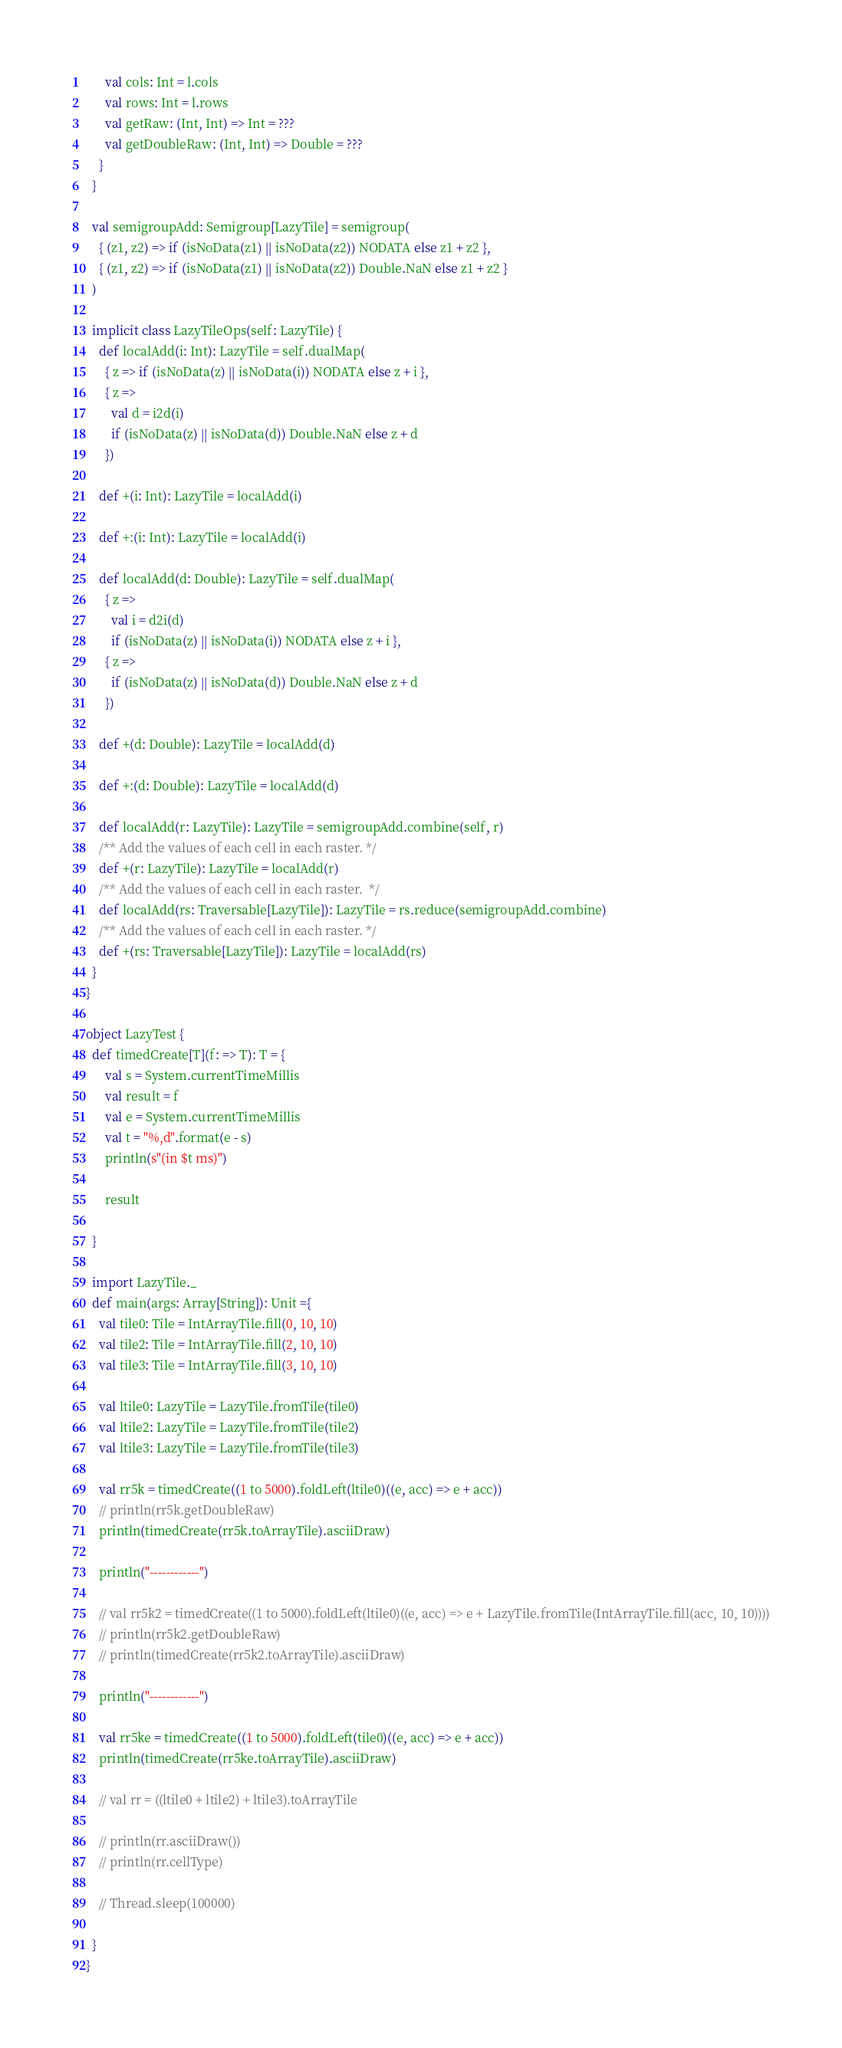<code> <loc_0><loc_0><loc_500><loc_500><_Scala_>      val cols: Int = l.cols
      val rows: Int = l.rows
      val getRaw: (Int, Int) => Int = ???
      val getDoubleRaw: (Int, Int) => Double = ???
    }
  }

  val semigroupAdd: Semigroup[LazyTile] = semigroup(
    { (z1, z2) => if (isNoData(z1) || isNoData(z2)) NODATA else z1 + z2 },
    { (z1, z2) => if (isNoData(z1) || isNoData(z2)) Double.NaN else z1 + z2 }
  )

  implicit class LazyTileOps(self: LazyTile) {
    def localAdd(i: Int): LazyTile = self.dualMap(
      { z => if (isNoData(z) || isNoData(i)) NODATA else z + i },
      { z =>
        val d = i2d(i)
        if (isNoData(z) || isNoData(d)) Double.NaN else z + d
      })

    def +(i: Int): LazyTile = localAdd(i)

    def +:(i: Int): LazyTile = localAdd(i)

    def localAdd(d: Double): LazyTile = self.dualMap(
      { z =>
        val i = d2i(d)
        if (isNoData(z) || isNoData(i)) NODATA else z + i },
      { z =>
        if (isNoData(z) || isNoData(d)) Double.NaN else z + d
      })

    def +(d: Double): LazyTile = localAdd(d)

    def +:(d: Double): LazyTile = localAdd(d)

    def localAdd(r: LazyTile): LazyTile = semigroupAdd.combine(self, r)
    /** Add the values of each cell in each raster. */
    def +(r: LazyTile): LazyTile = localAdd(r)
    /** Add the values of each cell in each raster.  */
    def localAdd(rs: Traversable[LazyTile]): LazyTile = rs.reduce(semigroupAdd.combine)
    /** Add the values of each cell in each raster. */
    def +(rs: Traversable[LazyTile]): LazyTile = localAdd(rs)
  }
}

object LazyTest {
  def timedCreate[T](f: => T): T = {
      val s = System.currentTimeMillis
      val result = f
      val e = System.currentTimeMillis
      val t = "%,d".format(e - s)
      println(s"(in $t ms)")

      result

  }

  import LazyTile._
  def main(args: Array[String]): Unit ={
    val tile0: Tile = IntArrayTile.fill(0, 10, 10)
    val tile2: Tile = IntArrayTile.fill(2, 10, 10)
    val tile3: Tile = IntArrayTile.fill(3, 10, 10)

    val ltile0: LazyTile = LazyTile.fromTile(tile0)
    val ltile2: LazyTile = LazyTile.fromTile(tile2)
    val ltile3: LazyTile = LazyTile.fromTile(tile3)

    val rr5k = timedCreate((1 to 5000).foldLeft(ltile0)((e, acc) => e + acc))
    // println(rr5k.getDoubleRaw)
    println(timedCreate(rr5k.toArrayTile).asciiDraw)

    println("------------")

    // val rr5k2 = timedCreate((1 to 5000).foldLeft(ltile0)((e, acc) => e + LazyTile.fromTile(IntArrayTile.fill(acc, 10, 10))))
    // println(rr5k2.getDoubleRaw)
    // println(timedCreate(rr5k2.toArrayTile).asciiDraw)

    println("------------")

    val rr5ke = timedCreate((1 to 5000).foldLeft(tile0)((e, acc) => e + acc))
    println(timedCreate(rr5ke.toArrayTile).asciiDraw)

    // val rr = ((ltile0 + ltile2) + ltile3).toArrayTile

    // println(rr.asciiDraw())
    // println(rr.cellType)

    // Thread.sleep(100000)

  }
}</code> 